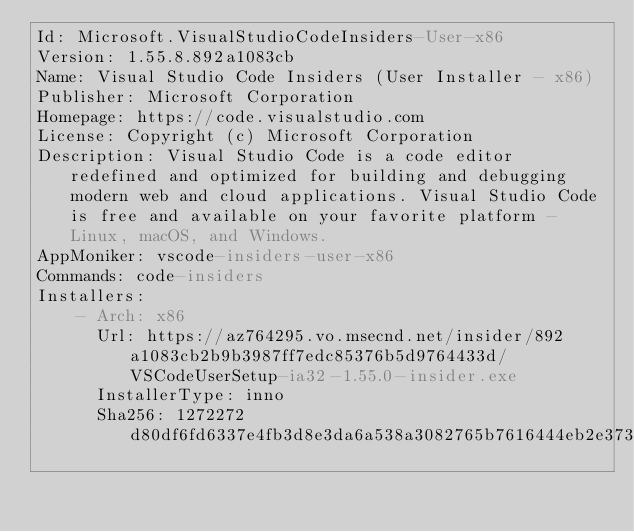Convert code to text. <code><loc_0><loc_0><loc_500><loc_500><_YAML_>Id: Microsoft.VisualStudioCodeInsiders-User-x86
Version: 1.55.8.892a1083cb
Name: Visual Studio Code Insiders (User Installer - x86)
Publisher: Microsoft Corporation
Homepage: https://code.visualstudio.com
License: Copyright (c) Microsoft Corporation
Description: Visual Studio Code is a code editor redefined and optimized for building and debugging modern web and cloud applications. Visual Studio Code is free and available on your favorite platform - Linux, macOS, and Windows.
AppMoniker: vscode-insiders-user-x86
Commands: code-insiders
Installers: 
    - Arch: x86
      Url: https://az764295.vo.msecnd.net/insider/892a1083cb2b9b3987ff7edc85376b5d9764433d/VSCodeUserSetup-ia32-1.55.0-insider.exe
      InstallerType: inno
      Sha256: 1272272d80df6fd6337e4fb3d8e3da6a538a3082765b7616444eb2e373db951a
</code> 